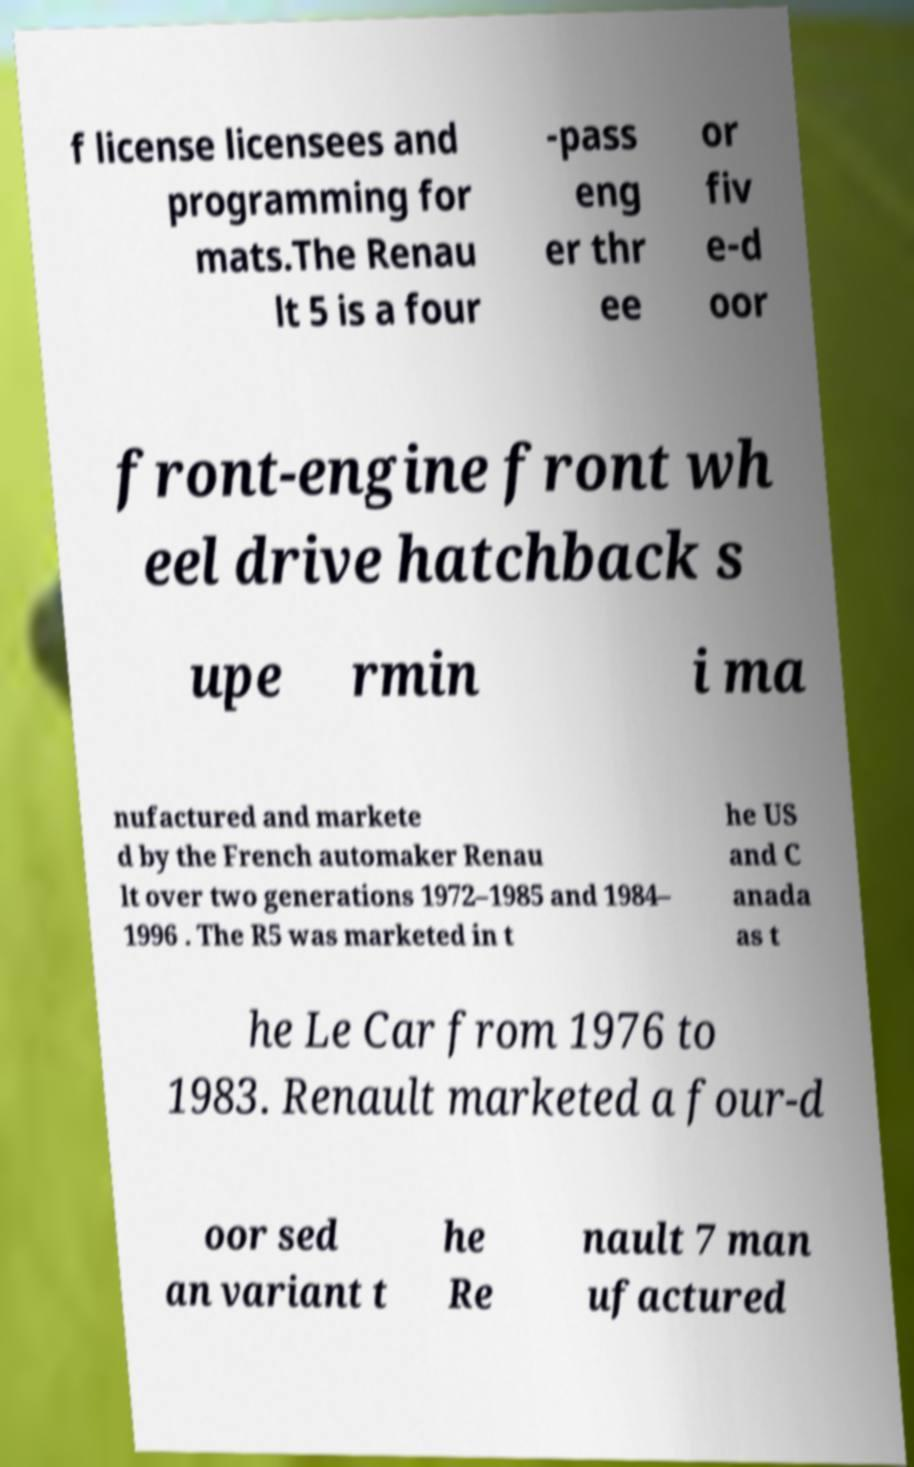Can you read and provide the text displayed in the image?This photo seems to have some interesting text. Can you extract and type it out for me? f license licensees and programming for mats.The Renau lt 5 is a four -pass eng er thr ee or fiv e-d oor front-engine front wh eel drive hatchback s upe rmin i ma nufactured and markete d by the French automaker Renau lt over two generations 1972–1985 and 1984– 1996 . The R5 was marketed in t he US and C anada as t he Le Car from 1976 to 1983. Renault marketed a four-d oor sed an variant t he Re nault 7 man ufactured 